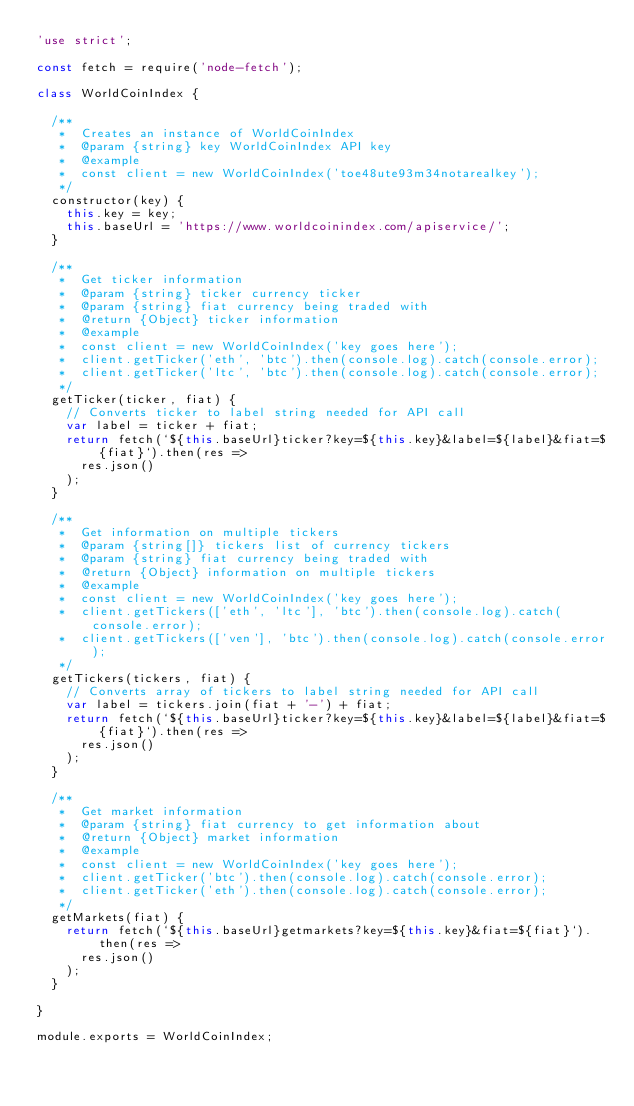<code> <loc_0><loc_0><loc_500><loc_500><_JavaScript_>'use strict';

const fetch = require('node-fetch');

class WorldCoinIndex {
  
  /**
   *  Creates an instance of WorldCoinIndex
   *  @param {string} key WorldCoinIndex API key
   *  @example
   *  const client = new WorldCoinIndex('toe48ute93m34notarealkey');
   */
  constructor(key) {
    this.key = key;
    this.baseUrl = 'https://www.worldcoinindex.com/apiservice/';
  }

  /**
   *  Get ticker information
   *  @param {string} ticker currency ticker
   *  @param {string} fiat currency being traded with
   *  @return {Object} ticker information
   *  @example
   *  const client = new WorldCoinIndex('key goes here');
   *  client.getTicker('eth', 'btc').then(console.log).catch(console.error);
   *  client.getTicker('ltc', 'btc').then(console.log).catch(console.error);
   */
  getTicker(ticker, fiat) {
    // Converts ticker to label string needed for API call
    var label = ticker + fiat;
    return fetch(`${this.baseUrl}ticker?key=${this.key}&label=${label}&fiat=${fiat}`).then(res => 
      res.json()
    );
  }

  /**
   *  Get information on multiple tickers
   *  @param {string[]} tickers list of currency tickers
   *  @param {string} fiat currency being traded with
   *  @return {Object} information on multiple tickers
   *  @example
   *  const client = new WorldCoinIndex('key goes here');
   *  client.getTickers(['eth', 'ltc'], 'btc').then(console.log).catch(console.error);
   *  client.getTickers(['ven'], 'btc').then(console.log).catch(console.error);
   */
  getTickers(tickers, fiat) {
    // Converts array of tickers to label string needed for API call
    var label = tickers.join(fiat + '-') + fiat;
    return fetch(`${this.baseUrl}ticker?key=${this.key}&label=${label}&fiat=${fiat}`).then(res => 
      res.json()
    );
  }

  /**
   *  Get market information
   *  @param {string} fiat currency to get information about
   *  @return {Object} market information
   *  @example
   *  const client = new WorldCoinIndex('key goes here');
   *  client.getTicker('btc').then(console.log).catch(console.error);
   *  client.getTicker('eth').then(console.log).catch(console.error);
   */
  getMarkets(fiat) {
    return fetch(`${this.baseUrl}getmarkets?key=${this.key}&fiat=${fiat}`).then(res => 
      res.json()
    );
  }

}

module.exports = WorldCoinIndex;</code> 